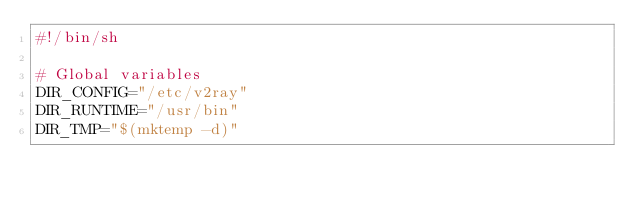Convert code to text. <code><loc_0><loc_0><loc_500><loc_500><_Bash_>#!/bin/sh

# Global variables
DIR_CONFIG="/etc/v2ray"
DIR_RUNTIME="/usr/bin"
DIR_TMP="$(mktemp -d)"
</code> 